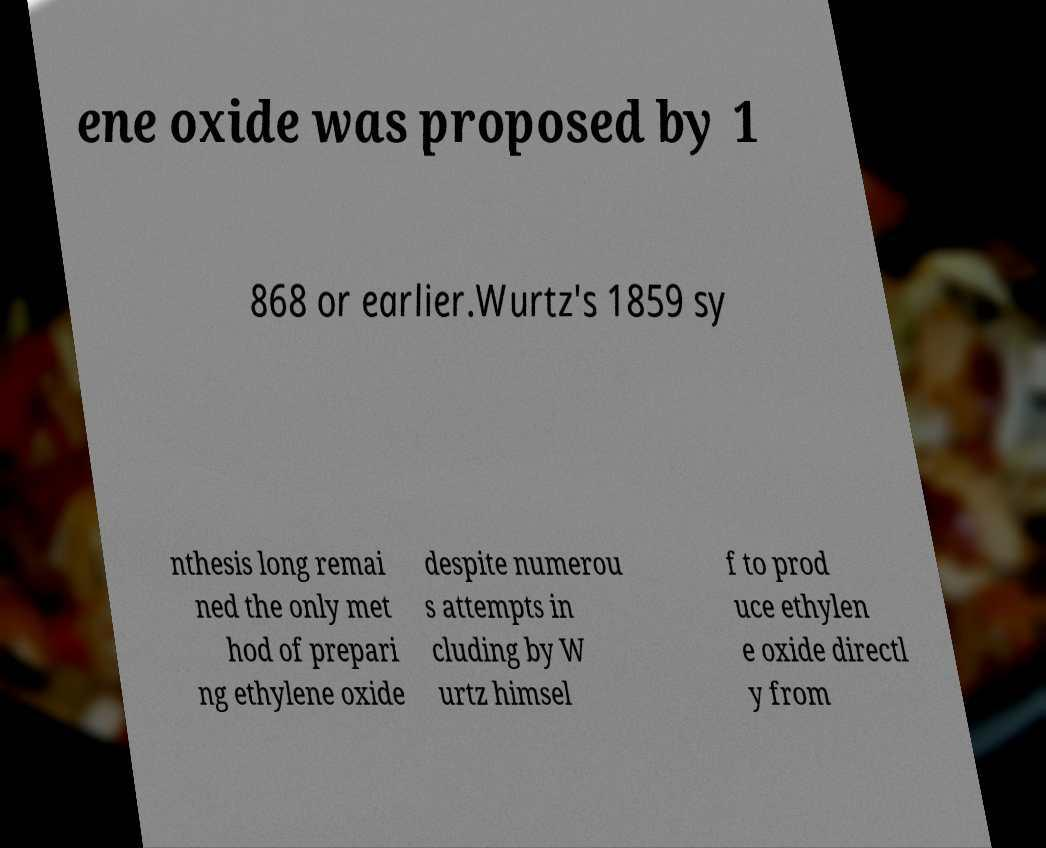Could you extract and type out the text from this image? ene oxide was proposed by 1 868 or earlier.Wurtz's 1859 sy nthesis long remai ned the only met hod of prepari ng ethylene oxide despite numerou s attempts in cluding by W urtz himsel f to prod uce ethylen e oxide directl y from 